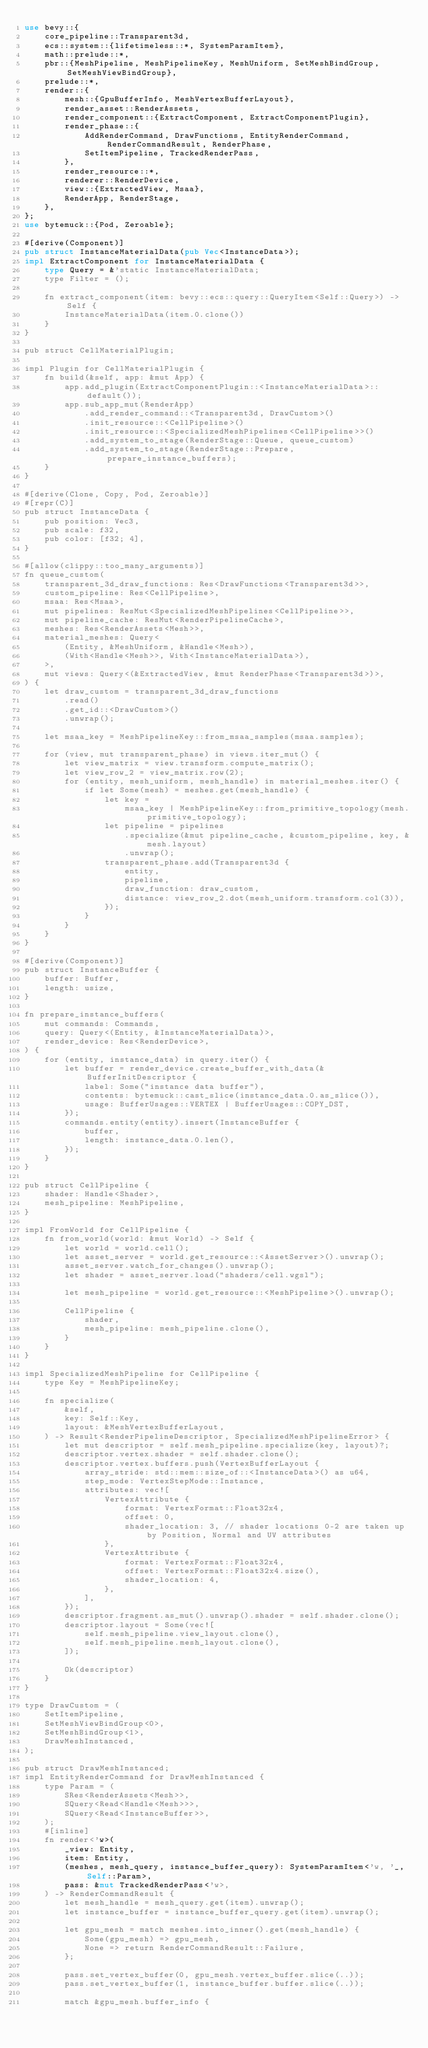<code> <loc_0><loc_0><loc_500><loc_500><_Rust_>use bevy::{
    core_pipeline::Transparent3d,
    ecs::system::{lifetimeless::*, SystemParamItem},
    math::prelude::*,
    pbr::{MeshPipeline, MeshPipelineKey, MeshUniform, SetMeshBindGroup, SetMeshViewBindGroup},
    prelude::*,
    render::{
        mesh::{GpuBufferInfo, MeshVertexBufferLayout},
        render_asset::RenderAssets,
        render_component::{ExtractComponent, ExtractComponentPlugin},
        render_phase::{
            AddRenderCommand, DrawFunctions, EntityRenderCommand, RenderCommandResult, RenderPhase,
            SetItemPipeline, TrackedRenderPass,
        },
        render_resource::*,
        renderer::RenderDevice,
        view::{ExtractedView, Msaa},
        RenderApp, RenderStage,
    },
};
use bytemuck::{Pod, Zeroable};

#[derive(Component)]
pub struct InstanceMaterialData(pub Vec<InstanceData>);
impl ExtractComponent for InstanceMaterialData {
    type Query = &'static InstanceMaterialData;
    type Filter = ();

    fn extract_component(item: bevy::ecs::query::QueryItem<Self::Query>) -> Self {
        InstanceMaterialData(item.0.clone())
    }
}

pub struct CellMaterialPlugin;

impl Plugin for CellMaterialPlugin {
    fn build(&self, app: &mut App) {
        app.add_plugin(ExtractComponentPlugin::<InstanceMaterialData>::default());
        app.sub_app_mut(RenderApp)
            .add_render_command::<Transparent3d, DrawCustom>()
            .init_resource::<CellPipeline>()
            .init_resource::<SpecializedMeshPipelines<CellPipeline>>()
            .add_system_to_stage(RenderStage::Queue, queue_custom)
            .add_system_to_stage(RenderStage::Prepare, prepare_instance_buffers);
    }
}

#[derive(Clone, Copy, Pod, Zeroable)]
#[repr(C)]
pub struct InstanceData {
    pub position: Vec3,
    pub scale: f32,
    pub color: [f32; 4],
}

#[allow(clippy::too_many_arguments)]
fn queue_custom(
    transparent_3d_draw_functions: Res<DrawFunctions<Transparent3d>>,
    custom_pipeline: Res<CellPipeline>,
    msaa: Res<Msaa>,
    mut pipelines: ResMut<SpecializedMeshPipelines<CellPipeline>>,
    mut pipeline_cache: ResMut<RenderPipelineCache>,
    meshes: Res<RenderAssets<Mesh>>,
    material_meshes: Query<
        (Entity, &MeshUniform, &Handle<Mesh>),
        (With<Handle<Mesh>>, With<InstanceMaterialData>),
    >,
    mut views: Query<(&ExtractedView, &mut RenderPhase<Transparent3d>)>,
) {
    let draw_custom = transparent_3d_draw_functions
        .read()
        .get_id::<DrawCustom>()
        .unwrap();

    let msaa_key = MeshPipelineKey::from_msaa_samples(msaa.samples);

    for (view, mut transparent_phase) in views.iter_mut() {
        let view_matrix = view.transform.compute_matrix();
        let view_row_2 = view_matrix.row(2);
        for (entity, mesh_uniform, mesh_handle) in material_meshes.iter() {
            if let Some(mesh) = meshes.get(mesh_handle) {
                let key =
                    msaa_key | MeshPipelineKey::from_primitive_topology(mesh.primitive_topology);
                let pipeline = pipelines
                    .specialize(&mut pipeline_cache, &custom_pipeline, key, &mesh.layout)
                    .unwrap();
                transparent_phase.add(Transparent3d {
                    entity,
                    pipeline,
                    draw_function: draw_custom,
                    distance: view_row_2.dot(mesh_uniform.transform.col(3)),
                });
            }
        }
    }
}

#[derive(Component)]
pub struct InstanceBuffer {
    buffer: Buffer,
    length: usize,
}

fn prepare_instance_buffers(
    mut commands: Commands,
    query: Query<(Entity, &InstanceMaterialData)>,
    render_device: Res<RenderDevice>,
) {
    for (entity, instance_data) in query.iter() {
        let buffer = render_device.create_buffer_with_data(&BufferInitDescriptor {
            label: Some("instance data buffer"),
            contents: bytemuck::cast_slice(instance_data.0.as_slice()),
            usage: BufferUsages::VERTEX | BufferUsages::COPY_DST,
        });
        commands.entity(entity).insert(InstanceBuffer {
            buffer,
            length: instance_data.0.len(),
        });
    }
}

pub struct CellPipeline {
    shader: Handle<Shader>,
    mesh_pipeline: MeshPipeline,
}

impl FromWorld for CellPipeline {
    fn from_world(world: &mut World) -> Self {
        let world = world.cell();
        let asset_server = world.get_resource::<AssetServer>().unwrap();
        asset_server.watch_for_changes().unwrap();
        let shader = asset_server.load("shaders/cell.wgsl");

        let mesh_pipeline = world.get_resource::<MeshPipeline>().unwrap();

        CellPipeline {
            shader,
            mesh_pipeline: mesh_pipeline.clone(),
        }
    }
}

impl SpecializedMeshPipeline for CellPipeline {
    type Key = MeshPipelineKey;

    fn specialize(
        &self,
        key: Self::Key,
        layout: &MeshVertexBufferLayout,
    ) -> Result<RenderPipelineDescriptor, SpecializedMeshPipelineError> {
        let mut descriptor = self.mesh_pipeline.specialize(key, layout)?;
        descriptor.vertex.shader = self.shader.clone();
        descriptor.vertex.buffers.push(VertexBufferLayout {
            array_stride: std::mem::size_of::<InstanceData>() as u64,
            step_mode: VertexStepMode::Instance,
            attributes: vec![
                VertexAttribute {
                    format: VertexFormat::Float32x4,
                    offset: 0,
                    shader_location: 3, // shader locations 0-2 are taken up by Position, Normal and UV attributes
                },
                VertexAttribute {
                    format: VertexFormat::Float32x4,
                    offset: VertexFormat::Float32x4.size(),
                    shader_location: 4,
                },
            ],
        });
        descriptor.fragment.as_mut().unwrap().shader = self.shader.clone();
        descriptor.layout = Some(vec![
            self.mesh_pipeline.view_layout.clone(),
            self.mesh_pipeline.mesh_layout.clone(),
        ]);

        Ok(descriptor)
    }
}

type DrawCustom = (
    SetItemPipeline,
    SetMeshViewBindGroup<0>,
    SetMeshBindGroup<1>,
    DrawMeshInstanced,
);

pub struct DrawMeshInstanced;
impl EntityRenderCommand for DrawMeshInstanced {
    type Param = (
        SRes<RenderAssets<Mesh>>,
        SQuery<Read<Handle<Mesh>>>,
        SQuery<Read<InstanceBuffer>>,
    );
    #[inline]
    fn render<'w>(
        _view: Entity,
        item: Entity,
        (meshes, mesh_query, instance_buffer_query): SystemParamItem<'w, '_, Self::Param>,
        pass: &mut TrackedRenderPass<'w>,
    ) -> RenderCommandResult {
        let mesh_handle = mesh_query.get(item).unwrap();
        let instance_buffer = instance_buffer_query.get(item).unwrap();

        let gpu_mesh = match meshes.into_inner().get(mesh_handle) {
            Some(gpu_mesh) => gpu_mesh,
            None => return RenderCommandResult::Failure,
        };

        pass.set_vertex_buffer(0, gpu_mesh.vertex_buffer.slice(..));
        pass.set_vertex_buffer(1, instance_buffer.buffer.slice(..));

        match &gpu_mesh.buffer_info {</code> 